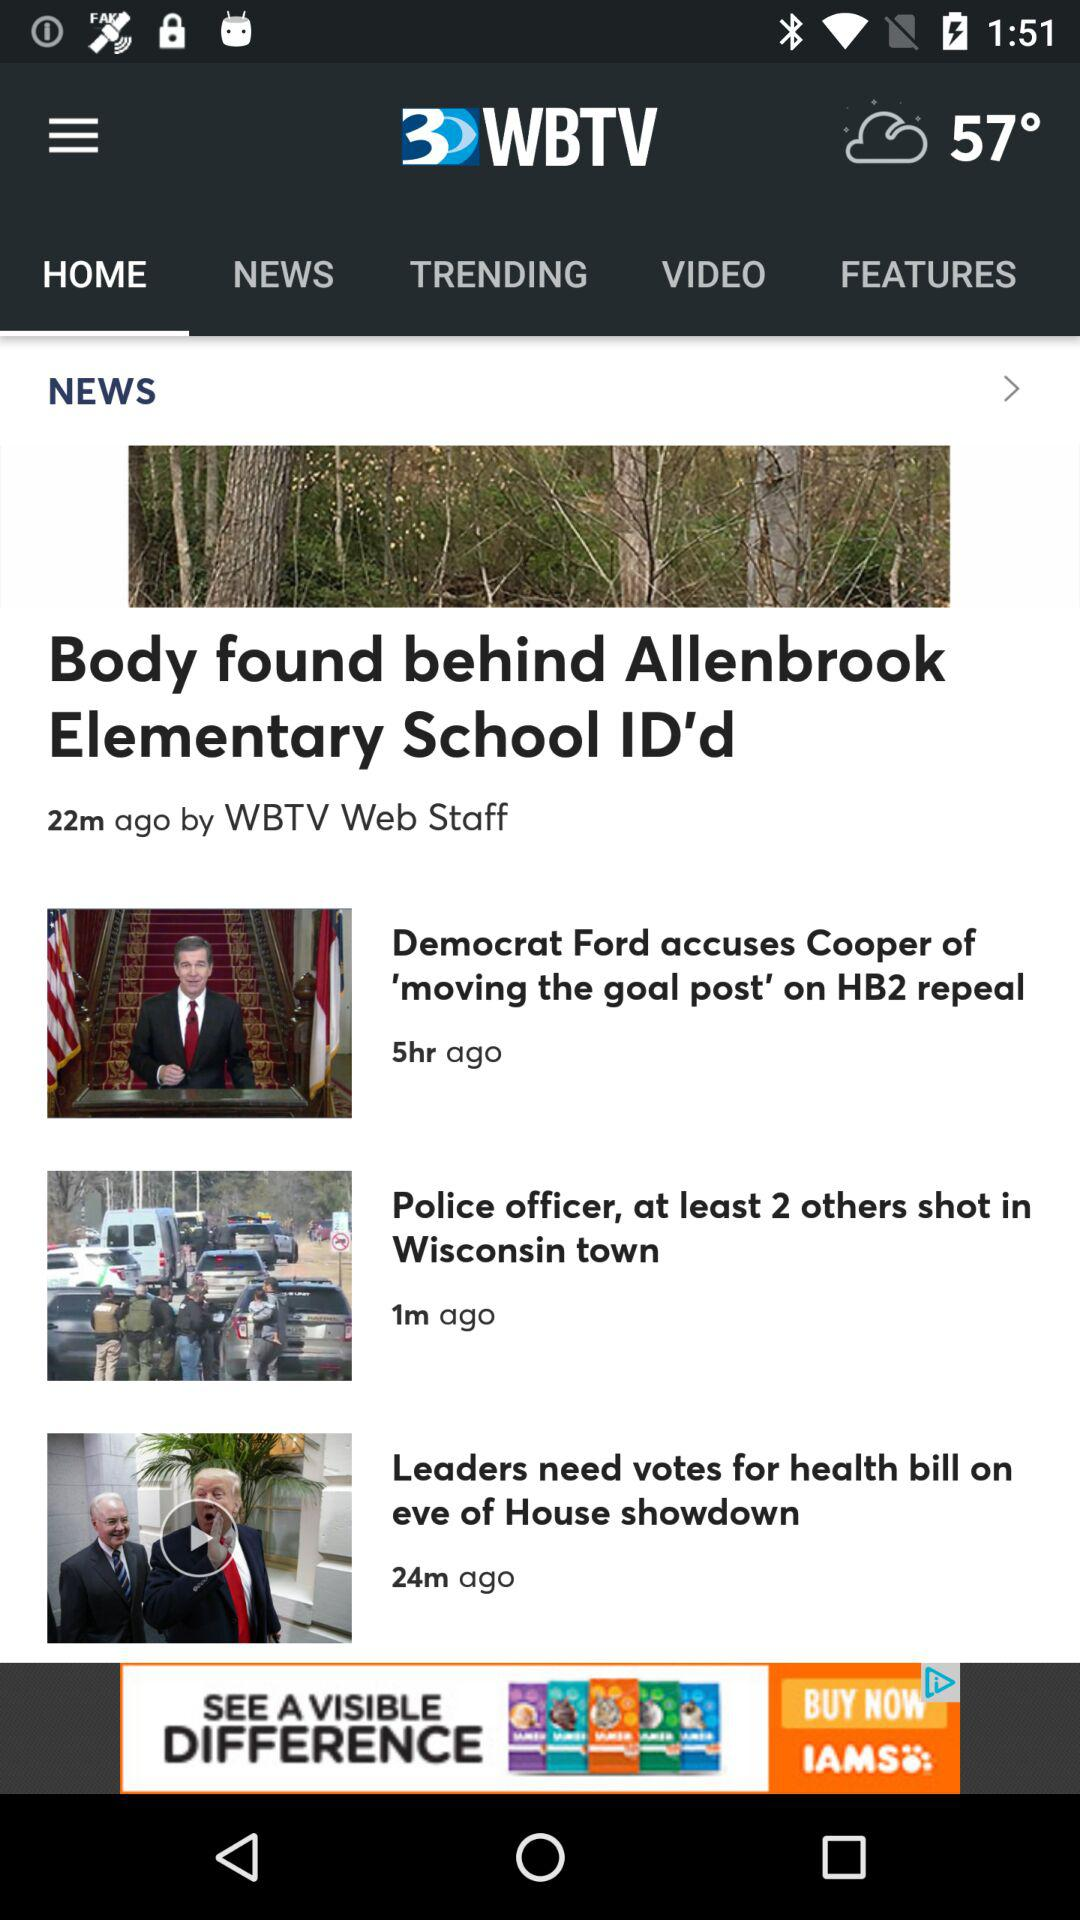What news was published one minute ago? The news was "Police officer, at least 2 others shot in Wisconsin town". 